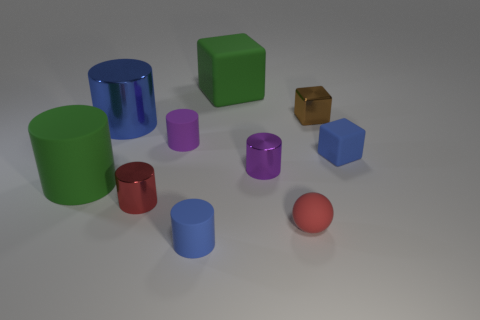Subtract all purple shiny cylinders. How many cylinders are left? 5 Subtract all green cylinders. How many cylinders are left? 5 Subtract all cyan cylinders. Subtract all brown blocks. How many cylinders are left? 6 Subtract all balls. How many objects are left? 9 Add 7 large gray rubber objects. How many large gray rubber objects exist? 7 Subtract 1 brown cubes. How many objects are left? 9 Subtract all large green objects. Subtract all blue shiny objects. How many objects are left? 7 Add 3 small red metallic cylinders. How many small red metallic cylinders are left? 4 